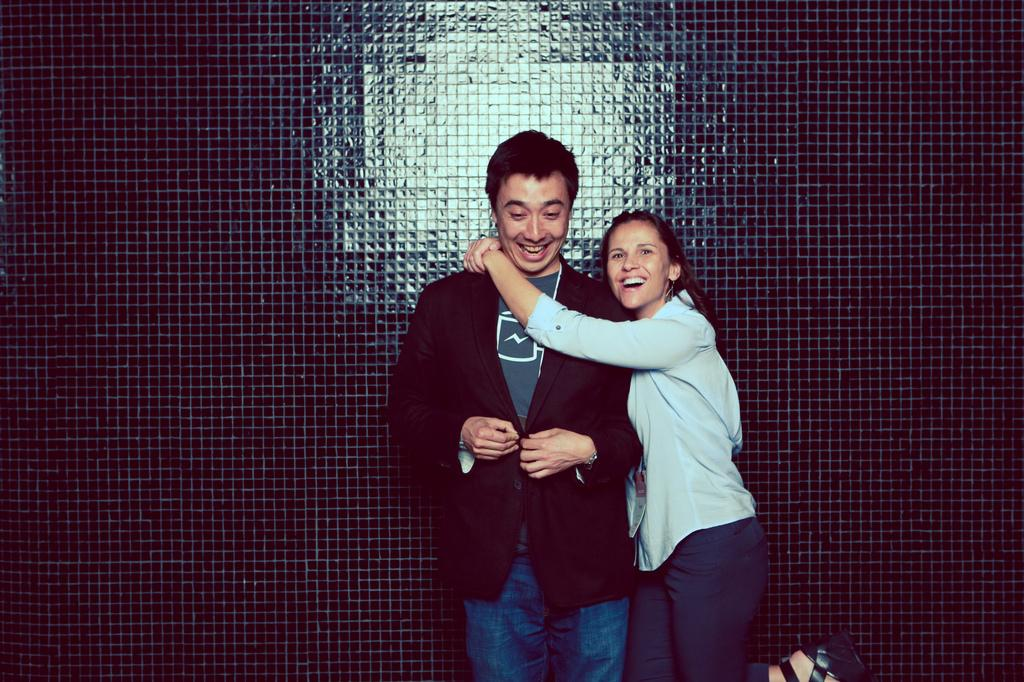How many people are in the image? There are two persons in the image. What is the facial expression of the persons? The persons are smiling. What can be seen in the background of the image? There is a wall visible in the image. What type of shoes can be seen on the wall in the image? There are no shoes visible on the wall in the image. What trick is being performed by the persons in the image? There is no trick being performed by the persons in the image; they are simply smiling. 